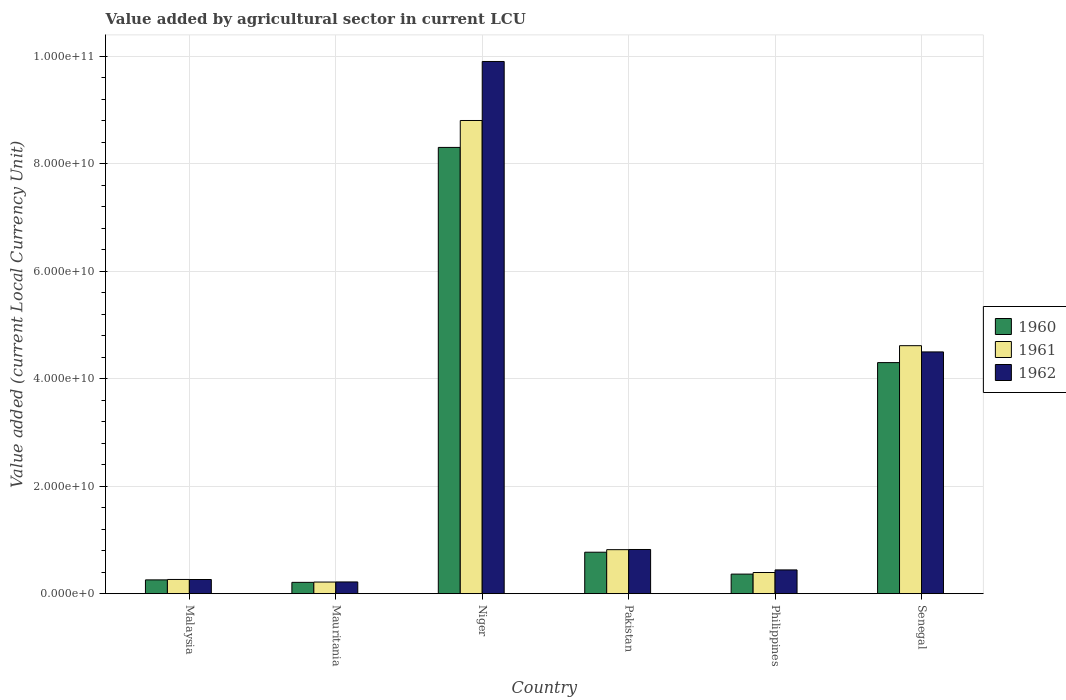Are the number of bars per tick equal to the number of legend labels?
Your answer should be compact. Yes. Are the number of bars on each tick of the X-axis equal?
Make the answer very short. Yes. How many bars are there on the 3rd tick from the left?
Provide a short and direct response. 3. What is the label of the 6th group of bars from the left?
Make the answer very short. Senegal. What is the value added by agricultural sector in 1962 in Niger?
Provide a succinct answer. 9.90e+1. Across all countries, what is the maximum value added by agricultural sector in 1960?
Ensure brevity in your answer.  8.30e+1. Across all countries, what is the minimum value added by agricultural sector in 1962?
Your response must be concise. 2.18e+09. In which country was the value added by agricultural sector in 1960 maximum?
Your answer should be very brief. Niger. In which country was the value added by agricultural sector in 1960 minimum?
Offer a very short reply. Mauritania. What is the total value added by agricultural sector in 1961 in the graph?
Keep it short and to the point. 1.51e+11. What is the difference between the value added by agricultural sector in 1962 in Malaysia and that in Senegal?
Ensure brevity in your answer.  -4.23e+1. What is the difference between the value added by agricultural sector in 1962 in Mauritania and the value added by agricultural sector in 1961 in Pakistan?
Your answer should be compact. -6.01e+09. What is the average value added by agricultural sector in 1962 per country?
Provide a succinct answer. 2.69e+1. What is the difference between the value added by agricultural sector of/in 1961 and value added by agricultural sector of/in 1960 in Philippines?
Make the answer very short. 2.97e+08. What is the ratio of the value added by agricultural sector in 1962 in Niger to that in Pakistan?
Ensure brevity in your answer.  12.05. What is the difference between the highest and the second highest value added by agricultural sector in 1961?
Make the answer very short. 3.80e+1. What is the difference between the highest and the lowest value added by agricultural sector in 1960?
Offer a terse response. 8.09e+1. What does the 1st bar from the right in Philippines represents?
Your answer should be compact. 1962. How many countries are there in the graph?
Offer a very short reply. 6. What is the difference between two consecutive major ticks on the Y-axis?
Keep it short and to the point. 2.00e+1. Where does the legend appear in the graph?
Your answer should be very brief. Center right. How many legend labels are there?
Provide a succinct answer. 3. How are the legend labels stacked?
Your response must be concise. Vertical. What is the title of the graph?
Offer a very short reply. Value added by agricultural sector in current LCU. What is the label or title of the Y-axis?
Ensure brevity in your answer.  Value added (current Local Currency Unit). What is the Value added (current Local Currency Unit) in 1960 in Malaysia?
Make the answer very short. 2.56e+09. What is the Value added (current Local Currency Unit) in 1961 in Malaysia?
Give a very brief answer. 2.64e+09. What is the Value added (current Local Currency Unit) in 1962 in Malaysia?
Offer a very short reply. 2.63e+09. What is the Value added (current Local Currency Unit) of 1960 in Mauritania?
Your answer should be very brief. 2.10e+09. What is the Value added (current Local Currency Unit) in 1961 in Mauritania?
Provide a short and direct response. 2.16e+09. What is the Value added (current Local Currency Unit) of 1962 in Mauritania?
Offer a very short reply. 2.18e+09. What is the Value added (current Local Currency Unit) of 1960 in Niger?
Give a very brief answer. 8.30e+1. What is the Value added (current Local Currency Unit) in 1961 in Niger?
Keep it short and to the point. 8.80e+1. What is the Value added (current Local Currency Unit) in 1962 in Niger?
Your answer should be compact. 9.90e+1. What is the Value added (current Local Currency Unit) in 1960 in Pakistan?
Offer a very short reply. 7.71e+09. What is the Value added (current Local Currency Unit) of 1961 in Pakistan?
Provide a succinct answer. 8.18e+09. What is the Value added (current Local Currency Unit) of 1962 in Pakistan?
Make the answer very short. 8.22e+09. What is the Value added (current Local Currency Unit) in 1960 in Philippines?
Your answer should be compact. 3.64e+09. What is the Value added (current Local Currency Unit) in 1961 in Philippines?
Provide a short and direct response. 3.94e+09. What is the Value added (current Local Currency Unit) in 1962 in Philippines?
Make the answer very short. 4.42e+09. What is the Value added (current Local Currency Unit) in 1960 in Senegal?
Provide a succinct answer. 4.30e+1. What is the Value added (current Local Currency Unit) of 1961 in Senegal?
Your answer should be compact. 4.61e+1. What is the Value added (current Local Currency Unit) in 1962 in Senegal?
Your response must be concise. 4.50e+1. Across all countries, what is the maximum Value added (current Local Currency Unit) in 1960?
Your response must be concise. 8.30e+1. Across all countries, what is the maximum Value added (current Local Currency Unit) of 1961?
Your response must be concise. 8.80e+1. Across all countries, what is the maximum Value added (current Local Currency Unit) in 1962?
Offer a very short reply. 9.90e+1. Across all countries, what is the minimum Value added (current Local Currency Unit) in 1960?
Give a very brief answer. 2.10e+09. Across all countries, what is the minimum Value added (current Local Currency Unit) in 1961?
Provide a succinct answer. 2.16e+09. Across all countries, what is the minimum Value added (current Local Currency Unit) in 1962?
Provide a short and direct response. 2.18e+09. What is the total Value added (current Local Currency Unit) in 1960 in the graph?
Offer a very short reply. 1.42e+11. What is the total Value added (current Local Currency Unit) of 1961 in the graph?
Your response must be concise. 1.51e+11. What is the total Value added (current Local Currency Unit) of 1962 in the graph?
Your response must be concise. 1.61e+11. What is the difference between the Value added (current Local Currency Unit) in 1960 in Malaysia and that in Mauritania?
Make the answer very short. 4.61e+08. What is the difference between the Value added (current Local Currency Unit) of 1961 in Malaysia and that in Mauritania?
Your response must be concise. 4.82e+08. What is the difference between the Value added (current Local Currency Unit) of 1962 in Malaysia and that in Mauritania?
Keep it short and to the point. 4.54e+08. What is the difference between the Value added (current Local Currency Unit) in 1960 in Malaysia and that in Niger?
Ensure brevity in your answer.  -8.05e+1. What is the difference between the Value added (current Local Currency Unit) of 1961 in Malaysia and that in Niger?
Ensure brevity in your answer.  -8.54e+1. What is the difference between the Value added (current Local Currency Unit) in 1962 in Malaysia and that in Niger?
Offer a very short reply. -9.64e+1. What is the difference between the Value added (current Local Currency Unit) of 1960 in Malaysia and that in Pakistan?
Offer a very short reply. -5.15e+09. What is the difference between the Value added (current Local Currency Unit) in 1961 in Malaysia and that in Pakistan?
Provide a succinct answer. -5.54e+09. What is the difference between the Value added (current Local Currency Unit) in 1962 in Malaysia and that in Pakistan?
Give a very brief answer. -5.58e+09. What is the difference between the Value added (current Local Currency Unit) in 1960 in Malaysia and that in Philippines?
Your response must be concise. -1.07e+09. What is the difference between the Value added (current Local Currency Unit) in 1961 in Malaysia and that in Philippines?
Your answer should be very brief. -1.29e+09. What is the difference between the Value added (current Local Currency Unit) in 1962 in Malaysia and that in Philippines?
Provide a succinct answer. -1.78e+09. What is the difference between the Value added (current Local Currency Unit) in 1960 in Malaysia and that in Senegal?
Make the answer very short. -4.04e+1. What is the difference between the Value added (current Local Currency Unit) of 1961 in Malaysia and that in Senegal?
Provide a succinct answer. -4.35e+1. What is the difference between the Value added (current Local Currency Unit) of 1962 in Malaysia and that in Senegal?
Offer a very short reply. -4.23e+1. What is the difference between the Value added (current Local Currency Unit) in 1960 in Mauritania and that in Niger?
Your answer should be compact. -8.09e+1. What is the difference between the Value added (current Local Currency Unit) in 1961 in Mauritania and that in Niger?
Ensure brevity in your answer.  -8.59e+1. What is the difference between the Value added (current Local Currency Unit) in 1962 in Mauritania and that in Niger?
Your response must be concise. -9.68e+1. What is the difference between the Value added (current Local Currency Unit) of 1960 in Mauritania and that in Pakistan?
Your response must be concise. -5.61e+09. What is the difference between the Value added (current Local Currency Unit) of 1961 in Mauritania and that in Pakistan?
Keep it short and to the point. -6.02e+09. What is the difference between the Value added (current Local Currency Unit) of 1962 in Mauritania and that in Pakistan?
Offer a terse response. -6.04e+09. What is the difference between the Value added (current Local Currency Unit) in 1960 in Mauritania and that in Philippines?
Ensure brevity in your answer.  -1.54e+09. What is the difference between the Value added (current Local Currency Unit) of 1961 in Mauritania and that in Philippines?
Your answer should be compact. -1.78e+09. What is the difference between the Value added (current Local Currency Unit) in 1962 in Mauritania and that in Philippines?
Keep it short and to the point. -2.24e+09. What is the difference between the Value added (current Local Currency Unit) of 1960 in Mauritania and that in Senegal?
Offer a terse response. -4.09e+1. What is the difference between the Value added (current Local Currency Unit) of 1961 in Mauritania and that in Senegal?
Provide a succinct answer. -4.40e+1. What is the difference between the Value added (current Local Currency Unit) in 1962 in Mauritania and that in Senegal?
Give a very brief answer. -4.28e+1. What is the difference between the Value added (current Local Currency Unit) of 1960 in Niger and that in Pakistan?
Make the answer very short. 7.53e+1. What is the difference between the Value added (current Local Currency Unit) in 1961 in Niger and that in Pakistan?
Make the answer very short. 7.98e+1. What is the difference between the Value added (current Local Currency Unit) in 1962 in Niger and that in Pakistan?
Offer a very short reply. 9.08e+1. What is the difference between the Value added (current Local Currency Unit) of 1960 in Niger and that in Philippines?
Give a very brief answer. 7.94e+1. What is the difference between the Value added (current Local Currency Unit) of 1961 in Niger and that in Philippines?
Provide a succinct answer. 8.41e+1. What is the difference between the Value added (current Local Currency Unit) of 1962 in Niger and that in Philippines?
Offer a very short reply. 9.46e+1. What is the difference between the Value added (current Local Currency Unit) in 1960 in Niger and that in Senegal?
Ensure brevity in your answer.  4.00e+1. What is the difference between the Value added (current Local Currency Unit) in 1961 in Niger and that in Senegal?
Give a very brief answer. 4.19e+1. What is the difference between the Value added (current Local Currency Unit) of 1962 in Niger and that in Senegal?
Ensure brevity in your answer.  5.40e+1. What is the difference between the Value added (current Local Currency Unit) in 1960 in Pakistan and that in Philippines?
Offer a very short reply. 4.07e+09. What is the difference between the Value added (current Local Currency Unit) in 1961 in Pakistan and that in Philippines?
Your response must be concise. 4.25e+09. What is the difference between the Value added (current Local Currency Unit) of 1962 in Pakistan and that in Philippines?
Make the answer very short. 3.80e+09. What is the difference between the Value added (current Local Currency Unit) of 1960 in Pakistan and that in Senegal?
Your response must be concise. -3.53e+1. What is the difference between the Value added (current Local Currency Unit) of 1961 in Pakistan and that in Senegal?
Provide a succinct answer. -3.80e+1. What is the difference between the Value added (current Local Currency Unit) in 1962 in Pakistan and that in Senegal?
Give a very brief answer. -3.68e+1. What is the difference between the Value added (current Local Currency Unit) in 1960 in Philippines and that in Senegal?
Keep it short and to the point. -3.94e+1. What is the difference between the Value added (current Local Currency Unit) of 1961 in Philippines and that in Senegal?
Offer a very short reply. -4.22e+1. What is the difference between the Value added (current Local Currency Unit) in 1962 in Philippines and that in Senegal?
Provide a succinct answer. -4.06e+1. What is the difference between the Value added (current Local Currency Unit) in 1960 in Malaysia and the Value added (current Local Currency Unit) in 1961 in Mauritania?
Your answer should be very brief. 4.04e+08. What is the difference between the Value added (current Local Currency Unit) of 1960 in Malaysia and the Value added (current Local Currency Unit) of 1962 in Mauritania?
Provide a short and direct response. 3.86e+08. What is the difference between the Value added (current Local Currency Unit) of 1961 in Malaysia and the Value added (current Local Currency Unit) of 1962 in Mauritania?
Your answer should be very brief. 4.63e+08. What is the difference between the Value added (current Local Currency Unit) of 1960 in Malaysia and the Value added (current Local Currency Unit) of 1961 in Niger?
Your response must be concise. -8.55e+1. What is the difference between the Value added (current Local Currency Unit) in 1960 in Malaysia and the Value added (current Local Currency Unit) in 1962 in Niger?
Ensure brevity in your answer.  -9.64e+1. What is the difference between the Value added (current Local Currency Unit) in 1961 in Malaysia and the Value added (current Local Currency Unit) in 1962 in Niger?
Keep it short and to the point. -9.64e+1. What is the difference between the Value added (current Local Currency Unit) in 1960 in Malaysia and the Value added (current Local Currency Unit) in 1961 in Pakistan?
Keep it short and to the point. -5.62e+09. What is the difference between the Value added (current Local Currency Unit) in 1960 in Malaysia and the Value added (current Local Currency Unit) in 1962 in Pakistan?
Your answer should be very brief. -5.65e+09. What is the difference between the Value added (current Local Currency Unit) of 1961 in Malaysia and the Value added (current Local Currency Unit) of 1962 in Pakistan?
Ensure brevity in your answer.  -5.57e+09. What is the difference between the Value added (current Local Currency Unit) of 1960 in Malaysia and the Value added (current Local Currency Unit) of 1961 in Philippines?
Ensure brevity in your answer.  -1.37e+09. What is the difference between the Value added (current Local Currency Unit) of 1960 in Malaysia and the Value added (current Local Currency Unit) of 1962 in Philippines?
Your answer should be very brief. -1.85e+09. What is the difference between the Value added (current Local Currency Unit) in 1961 in Malaysia and the Value added (current Local Currency Unit) in 1962 in Philippines?
Offer a very short reply. -1.77e+09. What is the difference between the Value added (current Local Currency Unit) of 1960 in Malaysia and the Value added (current Local Currency Unit) of 1961 in Senegal?
Provide a short and direct response. -4.36e+1. What is the difference between the Value added (current Local Currency Unit) in 1960 in Malaysia and the Value added (current Local Currency Unit) in 1962 in Senegal?
Make the answer very short. -4.24e+1. What is the difference between the Value added (current Local Currency Unit) of 1961 in Malaysia and the Value added (current Local Currency Unit) of 1962 in Senegal?
Make the answer very short. -4.23e+1. What is the difference between the Value added (current Local Currency Unit) in 1960 in Mauritania and the Value added (current Local Currency Unit) in 1961 in Niger?
Provide a succinct answer. -8.59e+1. What is the difference between the Value added (current Local Currency Unit) of 1960 in Mauritania and the Value added (current Local Currency Unit) of 1962 in Niger?
Make the answer very short. -9.69e+1. What is the difference between the Value added (current Local Currency Unit) in 1961 in Mauritania and the Value added (current Local Currency Unit) in 1962 in Niger?
Provide a short and direct response. -9.69e+1. What is the difference between the Value added (current Local Currency Unit) in 1960 in Mauritania and the Value added (current Local Currency Unit) in 1961 in Pakistan?
Give a very brief answer. -6.08e+09. What is the difference between the Value added (current Local Currency Unit) of 1960 in Mauritania and the Value added (current Local Currency Unit) of 1962 in Pakistan?
Your answer should be very brief. -6.11e+09. What is the difference between the Value added (current Local Currency Unit) in 1961 in Mauritania and the Value added (current Local Currency Unit) in 1962 in Pakistan?
Your response must be concise. -6.06e+09. What is the difference between the Value added (current Local Currency Unit) of 1960 in Mauritania and the Value added (current Local Currency Unit) of 1961 in Philippines?
Make the answer very short. -1.83e+09. What is the difference between the Value added (current Local Currency Unit) in 1960 in Mauritania and the Value added (current Local Currency Unit) in 1962 in Philippines?
Keep it short and to the point. -2.31e+09. What is the difference between the Value added (current Local Currency Unit) in 1961 in Mauritania and the Value added (current Local Currency Unit) in 1962 in Philippines?
Offer a very short reply. -2.26e+09. What is the difference between the Value added (current Local Currency Unit) in 1960 in Mauritania and the Value added (current Local Currency Unit) in 1961 in Senegal?
Offer a terse response. -4.40e+1. What is the difference between the Value added (current Local Currency Unit) of 1960 in Mauritania and the Value added (current Local Currency Unit) of 1962 in Senegal?
Give a very brief answer. -4.29e+1. What is the difference between the Value added (current Local Currency Unit) in 1961 in Mauritania and the Value added (current Local Currency Unit) in 1962 in Senegal?
Offer a terse response. -4.28e+1. What is the difference between the Value added (current Local Currency Unit) of 1960 in Niger and the Value added (current Local Currency Unit) of 1961 in Pakistan?
Give a very brief answer. 7.48e+1. What is the difference between the Value added (current Local Currency Unit) of 1960 in Niger and the Value added (current Local Currency Unit) of 1962 in Pakistan?
Make the answer very short. 7.48e+1. What is the difference between the Value added (current Local Currency Unit) of 1961 in Niger and the Value added (current Local Currency Unit) of 1962 in Pakistan?
Keep it short and to the point. 7.98e+1. What is the difference between the Value added (current Local Currency Unit) of 1960 in Niger and the Value added (current Local Currency Unit) of 1961 in Philippines?
Give a very brief answer. 7.91e+1. What is the difference between the Value added (current Local Currency Unit) in 1960 in Niger and the Value added (current Local Currency Unit) in 1962 in Philippines?
Provide a short and direct response. 7.86e+1. What is the difference between the Value added (current Local Currency Unit) in 1961 in Niger and the Value added (current Local Currency Unit) in 1962 in Philippines?
Your answer should be very brief. 8.36e+1. What is the difference between the Value added (current Local Currency Unit) in 1960 in Niger and the Value added (current Local Currency Unit) in 1961 in Senegal?
Your response must be concise. 3.69e+1. What is the difference between the Value added (current Local Currency Unit) of 1960 in Niger and the Value added (current Local Currency Unit) of 1962 in Senegal?
Your response must be concise. 3.80e+1. What is the difference between the Value added (current Local Currency Unit) of 1961 in Niger and the Value added (current Local Currency Unit) of 1962 in Senegal?
Ensure brevity in your answer.  4.31e+1. What is the difference between the Value added (current Local Currency Unit) in 1960 in Pakistan and the Value added (current Local Currency Unit) in 1961 in Philippines?
Offer a very short reply. 3.78e+09. What is the difference between the Value added (current Local Currency Unit) in 1960 in Pakistan and the Value added (current Local Currency Unit) in 1962 in Philippines?
Ensure brevity in your answer.  3.29e+09. What is the difference between the Value added (current Local Currency Unit) of 1961 in Pakistan and the Value added (current Local Currency Unit) of 1962 in Philippines?
Offer a terse response. 3.77e+09. What is the difference between the Value added (current Local Currency Unit) in 1960 in Pakistan and the Value added (current Local Currency Unit) in 1961 in Senegal?
Your response must be concise. -3.84e+1. What is the difference between the Value added (current Local Currency Unit) of 1960 in Pakistan and the Value added (current Local Currency Unit) of 1962 in Senegal?
Keep it short and to the point. -3.73e+1. What is the difference between the Value added (current Local Currency Unit) of 1961 in Pakistan and the Value added (current Local Currency Unit) of 1962 in Senegal?
Your answer should be very brief. -3.68e+1. What is the difference between the Value added (current Local Currency Unit) in 1960 in Philippines and the Value added (current Local Currency Unit) in 1961 in Senegal?
Provide a short and direct response. -4.25e+1. What is the difference between the Value added (current Local Currency Unit) in 1960 in Philippines and the Value added (current Local Currency Unit) in 1962 in Senegal?
Offer a very short reply. -4.13e+1. What is the difference between the Value added (current Local Currency Unit) in 1961 in Philippines and the Value added (current Local Currency Unit) in 1962 in Senegal?
Your response must be concise. -4.10e+1. What is the average Value added (current Local Currency Unit) in 1960 per country?
Provide a succinct answer. 2.37e+1. What is the average Value added (current Local Currency Unit) of 1961 per country?
Keep it short and to the point. 2.52e+1. What is the average Value added (current Local Currency Unit) in 1962 per country?
Give a very brief answer. 2.69e+1. What is the difference between the Value added (current Local Currency Unit) of 1960 and Value added (current Local Currency Unit) of 1961 in Malaysia?
Give a very brief answer. -7.78e+07. What is the difference between the Value added (current Local Currency Unit) in 1960 and Value added (current Local Currency Unit) in 1962 in Malaysia?
Make the answer very short. -6.83e+07. What is the difference between the Value added (current Local Currency Unit) of 1961 and Value added (current Local Currency Unit) of 1962 in Malaysia?
Provide a short and direct response. 9.46e+06. What is the difference between the Value added (current Local Currency Unit) in 1960 and Value added (current Local Currency Unit) in 1961 in Mauritania?
Offer a very short reply. -5.68e+07. What is the difference between the Value added (current Local Currency Unit) of 1960 and Value added (current Local Currency Unit) of 1962 in Mauritania?
Offer a terse response. -7.58e+07. What is the difference between the Value added (current Local Currency Unit) of 1961 and Value added (current Local Currency Unit) of 1962 in Mauritania?
Offer a very short reply. -1.89e+07. What is the difference between the Value added (current Local Currency Unit) of 1960 and Value added (current Local Currency Unit) of 1961 in Niger?
Keep it short and to the point. -5.01e+09. What is the difference between the Value added (current Local Currency Unit) of 1960 and Value added (current Local Currency Unit) of 1962 in Niger?
Provide a short and direct response. -1.60e+1. What is the difference between the Value added (current Local Currency Unit) in 1961 and Value added (current Local Currency Unit) in 1962 in Niger?
Give a very brief answer. -1.10e+1. What is the difference between the Value added (current Local Currency Unit) in 1960 and Value added (current Local Currency Unit) in 1961 in Pakistan?
Offer a very short reply. -4.73e+08. What is the difference between the Value added (current Local Currency Unit) of 1960 and Value added (current Local Currency Unit) of 1962 in Pakistan?
Give a very brief answer. -5.05e+08. What is the difference between the Value added (current Local Currency Unit) in 1961 and Value added (current Local Currency Unit) in 1962 in Pakistan?
Offer a terse response. -3.20e+07. What is the difference between the Value added (current Local Currency Unit) of 1960 and Value added (current Local Currency Unit) of 1961 in Philippines?
Keep it short and to the point. -2.97e+08. What is the difference between the Value added (current Local Currency Unit) in 1960 and Value added (current Local Currency Unit) in 1962 in Philippines?
Give a very brief answer. -7.78e+08. What is the difference between the Value added (current Local Currency Unit) of 1961 and Value added (current Local Currency Unit) of 1962 in Philippines?
Keep it short and to the point. -4.81e+08. What is the difference between the Value added (current Local Currency Unit) in 1960 and Value added (current Local Currency Unit) in 1961 in Senegal?
Your answer should be compact. -3.15e+09. What is the difference between the Value added (current Local Currency Unit) in 1960 and Value added (current Local Currency Unit) in 1962 in Senegal?
Offer a very short reply. -1.99e+09. What is the difference between the Value added (current Local Currency Unit) in 1961 and Value added (current Local Currency Unit) in 1962 in Senegal?
Make the answer very short. 1.16e+09. What is the ratio of the Value added (current Local Currency Unit) of 1960 in Malaysia to that in Mauritania?
Your answer should be compact. 1.22. What is the ratio of the Value added (current Local Currency Unit) of 1961 in Malaysia to that in Mauritania?
Your answer should be very brief. 1.22. What is the ratio of the Value added (current Local Currency Unit) of 1962 in Malaysia to that in Mauritania?
Provide a succinct answer. 1.21. What is the ratio of the Value added (current Local Currency Unit) in 1960 in Malaysia to that in Niger?
Provide a succinct answer. 0.03. What is the ratio of the Value added (current Local Currency Unit) in 1962 in Malaysia to that in Niger?
Provide a succinct answer. 0.03. What is the ratio of the Value added (current Local Currency Unit) of 1960 in Malaysia to that in Pakistan?
Offer a very short reply. 0.33. What is the ratio of the Value added (current Local Currency Unit) of 1961 in Malaysia to that in Pakistan?
Give a very brief answer. 0.32. What is the ratio of the Value added (current Local Currency Unit) in 1962 in Malaysia to that in Pakistan?
Keep it short and to the point. 0.32. What is the ratio of the Value added (current Local Currency Unit) in 1960 in Malaysia to that in Philippines?
Your response must be concise. 0.7. What is the ratio of the Value added (current Local Currency Unit) in 1961 in Malaysia to that in Philippines?
Offer a very short reply. 0.67. What is the ratio of the Value added (current Local Currency Unit) in 1962 in Malaysia to that in Philippines?
Provide a succinct answer. 0.6. What is the ratio of the Value added (current Local Currency Unit) in 1960 in Malaysia to that in Senegal?
Your response must be concise. 0.06. What is the ratio of the Value added (current Local Currency Unit) of 1961 in Malaysia to that in Senegal?
Give a very brief answer. 0.06. What is the ratio of the Value added (current Local Currency Unit) in 1962 in Malaysia to that in Senegal?
Give a very brief answer. 0.06. What is the ratio of the Value added (current Local Currency Unit) of 1960 in Mauritania to that in Niger?
Your answer should be very brief. 0.03. What is the ratio of the Value added (current Local Currency Unit) in 1961 in Mauritania to that in Niger?
Your answer should be compact. 0.02. What is the ratio of the Value added (current Local Currency Unit) of 1962 in Mauritania to that in Niger?
Ensure brevity in your answer.  0.02. What is the ratio of the Value added (current Local Currency Unit) of 1960 in Mauritania to that in Pakistan?
Give a very brief answer. 0.27. What is the ratio of the Value added (current Local Currency Unit) in 1961 in Mauritania to that in Pakistan?
Provide a short and direct response. 0.26. What is the ratio of the Value added (current Local Currency Unit) of 1962 in Mauritania to that in Pakistan?
Your answer should be very brief. 0.27. What is the ratio of the Value added (current Local Currency Unit) of 1960 in Mauritania to that in Philippines?
Offer a terse response. 0.58. What is the ratio of the Value added (current Local Currency Unit) of 1961 in Mauritania to that in Philippines?
Offer a terse response. 0.55. What is the ratio of the Value added (current Local Currency Unit) of 1962 in Mauritania to that in Philippines?
Your answer should be very brief. 0.49. What is the ratio of the Value added (current Local Currency Unit) in 1960 in Mauritania to that in Senegal?
Ensure brevity in your answer.  0.05. What is the ratio of the Value added (current Local Currency Unit) in 1961 in Mauritania to that in Senegal?
Your answer should be compact. 0.05. What is the ratio of the Value added (current Local Currency Unit) in 1962 in Mauritania to that in Senegal?
Provide a short and direct response. 0.05. What is the ratio of the Value added (current Local Currency Unit) in 1960 in Niger to that in Pakistan?
Ensure brevity in your answer.  10.77. What is the ratio of the Value added (current Local Currency Unit) of 1961 in Niger to that in Pakistan?
Ensure brevity in your answer.  10.76. What is the ratio of the Value added (current Local Currency Unit) in 1962 in Niger to that in Pakistan?
Offer a very short reply. 12.05. What is the ratio of the Value added (current Local Currency Unit) in 1960 in Niger to that in Philippines?
Provide a short and direct response. 22.82. What is the ratio of the Value added (current Local Currency Unit) in 1961 in Niger to that in Philippines?
Make the answer very short. 22.37. What is the ratio of the Value added (current Local Currency Unit) of 1962 in Niger to that in Philippines?
Offer a terse response. 22.42. What is the ratio of the Value added (current Local Currency Unit) in 1960 in Niger to that in Senegal?
Make the answer very short. 1.93. What is the ratio of the Value added (current Local Currency Unit) of 1961 in Niger to that in Senegal?
Your answer should be very brief. 1.91. What is the ratio of the Value added (current Local Currency Unit) in 1962 in Niger to that in Senegal?
Your answer should be very brief. 2.2. What is the ratio of the Value added (current Local Currency Unit) of 1960 in Pakistan to that in Philippines?
Your response must be concise. 2.12. What is the ratio of the Value added (current Local Currency Unit) of 1961 in Pakistan to that in Philippines?
Give a very brief answer. 2.08. What is the ratio of the Value added (current Local Currency Unit) of 1962 in Pakistan to that in Philippines?
Keep it short and to the point. 1.86. What is the ratio of the Value added (current Local Currency Unit) of 1960 in Pakistan to that in Senegal?
Provide a short and direct response. 0.18. What is the ratio of the Value added (current Local Currency Unit) in 1961 in Pakistan to that in Senegal?
Your answer should be very brief. 0.18. What is the ratio of the Value added (current Local Currency Unit) in 1962 in Pakistan to that in Senegal?
Provide a short and direct response. 0.18. What is the ratio of the Value added (current Local Currency Unit) of 1960 in Philippines to that in Senegal?
Provide a succinct answer. 0.08. What is the ratio of the Value added (current Local Currency Unit) of 1961 in Philippines to that in Senegal?
Make the answer very short. 0.09. What is the ratio of the Value added (current Local Currency Unit) of 1962 in Philippines to that in Senegal?
Provide a short and direct response. 0.1. What is the difference between the highest and the second highest Value added (current Local Currency Unit) of 1960?
Offer a very short reply. 4.00e+1. What is the difference between the highest and the second highest Value added (current Local Currency Unit) in 1961?
Give a very brief answer. 4.19e+1. What is the difference between the highest and the second highest Value added (current Local Currency Unit) of 1962?
Make the answer very short. 5.40e+1. What is the difference between the highest and the lowest Value added (current Local Currency Unit) in 1960?
Offer a very short reply. 8.09e+1. What is the difference between the highest and the lowest Value added (current Local Currency Unit) of 1961?
Provide a short and direct response. 8.59e+1. What is the difference between the highest and the lowest Value added (current Local Currency Unit) in 1962?
Keep it short and to the point. 9.68e+1. 